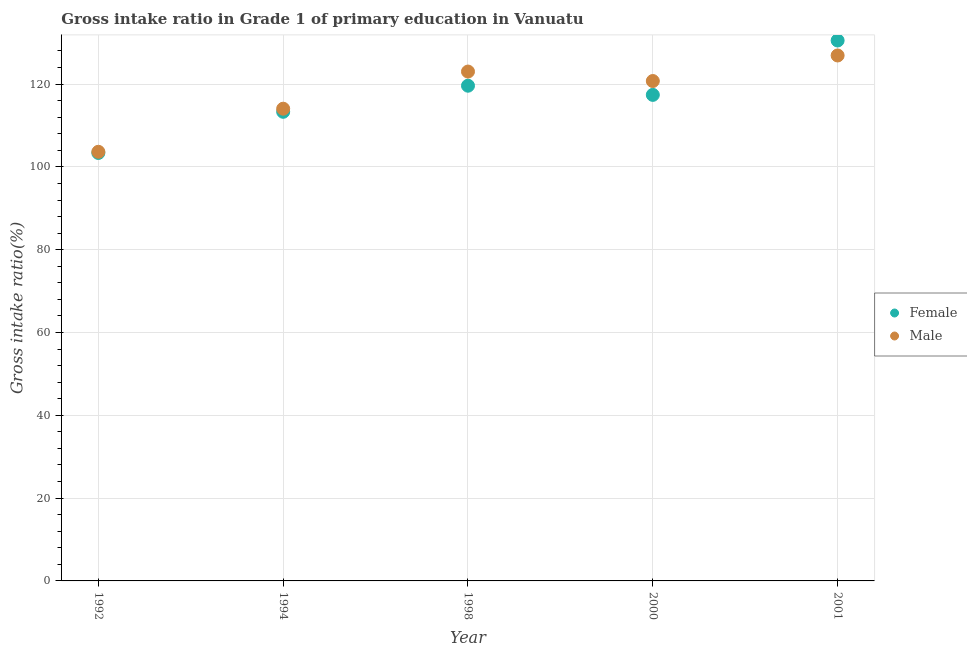How many different coloured dotlines are there?
Keep it short and to the point. 2. Is the number of dotlines equal to the number of legend labels?
Offer a very short reply. Yes. What is the gross intake ratio(male) in 2001?
Provide a succinct answer. 126.9. Across all years, what is the maximum gross intake ratio(female)?
Ensure brevity in your answer.  130.52. Across all years, what is the minimum gross intake ratio(male)?
Your answer should be compact. 103.64. In which year was the gross intake ratio(female) maximum?
Offer a very short reply. 2001. In which year was the gross intake ratio(female) minimum?
Provide a succinct answer. 1992. What is the total gross intake ratio(female) in the graph?
Offer a terse response. 584.18. What is the difference between the gross intake ratio(male) in 1998 and that in 2001?
Provide a succinct answer. -3.88. What is the difference between the gross intake ratio(female) in 1998 and the gross intake ratio(male) in 2000?
Keep it short and to the point. -1.13. What is the average gross intake ratio(male) per year?
Offer a terse response. 117.67. In the year 1992, what is the difference between the gross intake ratio(male) and gross intake ratio(female)?
Provide a succinct answer. 0.28. What is the ratio of the gross intake ratio(female) in 1998 to that in 2000?
Offer a very short reply. 1.02. Is the difference between the gross intake ratio(male) in 1992 and 2000 greater than the difference between the gross intake ratio(female) in 1992 and 2000?
Your answer should be very brief. No. What is the difference between the highest and the second highest gross intake ratio(male)?
Provide a succinct answer. 3.88. What is the difference between the highest and the lowest gross intake ratio(female)?
Your answer should be very brief. 27.16. In how many years, is the gross intake ratio(female) greater than the average gross intake ratio(female) taken over all years?
Ensure brevity in your answer.  3. Is the sum of the gross intake ratio(female) in 1994 and 1998 greater than the maximum gross intake ratio(male) across all years?
Your answer should be very brief. Yes. Does the gross intake ratio(male) monotonically increase over the years?
Give a very brief answer. No. Is the gross intake ratio(female) strictly greater than the gross intake ratio(male) over the years?
Ensure brevity in your answer.  No. Are the values on the major ticks of Y-axis written in scientific E-notation?
Your response must be concise. No. Does the graph contain grids?
Provide a succinct answer. Yes. Where does the legend appear in the graph?
Provide a succinct answer. Center right. What is the title of the graph?
Offer a terse response. Gross intake ratio in Grade 1 of primary education in Vanuatu. Does "Transport services" appear as one of the legend labels in the graph?
Give a very brief answer. No. What is the label or title of the Y-axis?
Make the answer very short. Gross intake ratio(%). What is the Gross intake ratio(%) in Female in 1992?
Ensure brevity in your answer.  103.36. What is the Gross intake ratio(%) in Male in 1992?
Your response must be concise. 103.64. What is the Gross intake ratio(%) of Female in 1994?
Give a very brief answer. 113.3. What is the Gross intake ratio(%) of Male in 1994?
Keep it short and to the point. 114.05. What is the Gross intake ratio(%) of Female in 1998?
Offer a very short reply. 119.6. What is the Gross intake ratio(%) in Male in 1998?
Provide a succinct answer. 123.02. What is the Gross intake ratio(%) of Female in 2000?
Provide a short and direct response. 117.39. What is the Gross intake ratio(%) in Male in 2000?
Give a very brief answer. 120.73. What is the Gross intake ratio(%) of Female in 2001?
Your response must be concise. 130.52. What is the Gross intake ratio(%) of Male in 2001?
Make the answer very short. 126.9. Across all years, what is the maximum Gross intake ratio(%) of Female?
Offer a very short reply. 130.52. Across all years, what is the maximum Gross intake ratio(%) of Male?
Offer a very short reply. 126.9. Across all years, what is the minimum Gross intake ratio(%) of Female?
Offer a terse response. 103.36. Across all years, what is the minimum Gross intake ratio(%) of Male?
Make the answer very short. 103.64. What is the total Gross intake ratio(%) of Female in the graph?
Provide a succinct answer. 584.18. What is the total Gross intake ratio(%) in Male in the graph?
Offer a very short reply. 588.35. What is the difference between the Gross intake ratio(%) of Female in 1992 and that in 1994?
Your response must be concise. -9.94. What is the difference between the Gross intake ratio(%) of Male in 1992 and that in 1994?
Your answer should be compact. -10.41. What is the difference between the Gross intake ratio(%) in Female in 1992 and that in 1998?
Keep it short and to the point. -16.24. What is the difference between the Gross intake ratio(%) in Male in 1992 and that in 1998?
Provide a succinct answer. -19.38. What is the difference between the Gross intake ratio(%) in Female in 1992 and that in 2000?
Your answer should be very brief. -14.03. What is the difference between the Gross intake ratio(%) of Male in 1992 and that in 2000?
Provide a short and direct response. -17.09. What is the difference between the Gross intake ratio(%) of Female in 1992 and that in 2001?
Provide a short and direct response. -27.16. What is the difference between the Gross intake ratio(%) in Male in 1992 and that in 2001?
Give a very brief answer. -23.26. What is the difference between the Gross intake ratio(%) in Female in 1994 and that in 1998?
Your answer should be very brief. -6.3. What is the difference between the Gross intake ratio(%) in Male in 1994 and that in 1998?
Keep it short and to the point. -8.97. What is the difference between the Gross intake ratio(%) of Female in 1994 and that in 2000?
Your answer should be very brief. -4.09. What is the difference between the Gross intake ratio(%) in Male in 1994 and that in 2000?
Offer a terse response. -6.69. What is the difference between the Gross intake ratio(%) in Female in 1994 and that in 2001?
Offer a terse response. -17.22. What is the difference between the Gross intake ratio(%) of Male in 1994 and that in 2001?
Ensure brevity in your answer.  -12.86. What is the difference between the Gross intake ratio(%) of Female in 1998 and that in 2000?
Keep it short and to the point. 2.22. What is the difference between the Gross intake ratio(%) in Male in 1998 and that in 2000?
Offer a very short reply. 2.29. What is the difference between the Gross intake ratio(%) of Female in 1998 and that in 2001?
Offer a terse response. -10.92. What is the difference between the Gross intake ratio(%) in Male in 1998 and that in 2001?
Provide a short and direct response. -3.88. What is the difference between the Gross intake ratio(%) of Female in 2000 and that in 2001?
Make the answer very short. -13.14. What is the difference between the Gross intake ratio(%) in Male in 2000 and that in 2001?
Provide a short and direct response. -6.17. What is the difference between the Gross intake ratio(%) in Female in 1992 and the Gross intake ratio(%) in Male in 1994?
Your answer should be very brief. -10.69. What is the difference between the Gross intake ratio(%) in Female in 1992 and the Gross intake ratio(%) in Male in 1998?
Your answer should be compact. -19.66. What is the difference between the Gross intake ratio(%) in Female in 1992 and the Gross intake ratio(%) in Male in 2000?
Your answer should be compact. -17.37. What is the difference between the Gross intake ratio(%) in Female in 1992 and the Gross intake ratio(%) in Male in 2001?
Offer a very short reply. -23.54. What is the difference between the Gross intake ratio(%) of Female in 1994 and the Gross intake ratio(%) of Male in 1998?
Provide a succinct answer. -9.72. What is the difference between the Gross intake ratio(%) of Female in 1994 and the Gross intake ratio(%) of Male in 2000?
Make the answer very short. -7.43. What is the difference between the Gross intake ratio(%) of Female in 1994 and the Gross intake ratio(%) of Male in 2001?
Give a very brief answer. -13.6. What is the difference between the Gross intake ratio(%) of Female in 1998 and the Gross intake ratio(%) of Male in 2000?
Provide a succinct answer. -1.13. What is the difference between the Gross intake ratio(%) in Female in 1998 and the Gross intake ratio(%) in Male in 2001?
Provide a succinct answer. -7.3. What is the difference between the Gross intake ratio(%) in Female in 2000 and the Gross intake ratio(%) in Male in 2001?
Keep it short and to the point. -9.52. What is the average Gross intake ratio(%) in Female per year?
Provide a succinct answer. 116.84. What is the average Gross intake ratio(%) of Male per year?
Provide a succinct answer. 117.67. In the year 1992, what is the difference between the Gross intake ratio(%) of Female and Gross intake ratio(%) of Male?
Give a very brief answer. -0.28. In the year 1994, what is the difference between the Gross intake ratio(%) in Female and Gross intake ratio(%) in Male?
Offer a very short reply. -0.75. In the year 1998, what is the difference between the Gross intake ratio(%) in Female and Gross intake ratio(%) in Male?
Your response must be concise. -3.42. In the year 2000, what is the difference between the Gross intake ratio(%) of Female and Gross intake ratio(%) of Male?
Ensure brevity in your answer.  -3.35. In the year 2001, what is the difference between the Gross intake ratio(%) of Female and Gross intake ratio(%) of Male?
Provide a succinct answer. 3.62. What is the ratio of the Gross intake ratio(%) of Female in 1992 to that in 1994?
Keep it short and to the point. 0.91. What is the ratio of the Gross intake ratio(%) in Male in 1992 to that in 1994?
Provide a short and direct response. 0.91. What is the ratio of the Gross intake ratio(%) of Female in 1992 to that in 1998?
Your answer should be very brief. 0.86. What is the ratio of the Gross intake ratio(%) of Male in 1992 to that in 1998?
Offer a very short reply. 0.84. What is the ratio of the Gross intake ratio(%) of Female in 1992 to that in 2000?
Give a very brief answer. 0.88. What is the ratio of the Gross intake ratio(%) of Male in 1992 to that in 2000?
Ensure brevity in your answer.  0.86. What is the ratio of the Gross intake ratio(%) in Female in 1992 to that in 2001?
Your answer should be compact. 0.79. What is the ratio of the Gross intake ratio(%) in Male in 1992 to that in 2001?
Offer a terse response. 0.82. What is the ratio of the Gross intake ratio(%) of Female in 1994 to that in 1998?
Make the answer very short. 0.95. What is the ratio of the Gross intake ratio(%) of Male in 1994 to that in 1998?
Provide a short and direct response. 0.93. What is the ratio of the Gross intake ratio(%) in Female in 1994 to that in 2000?
Your answer should be very brief. 0.97. What is the ratio of the Gross intake ratio(%) in Male in 1994 to that in 2000?
Your answer should be very brief. 0.94. What is the ratio of the Gross intake ratio(%) in Female in 1994 to that in 2001?
Make the answer very short. 0.87. What is the ratio of the Gross intake ratio(%) in Male in 1994 to that in 2001?
Offer a very short reply. 0.9. What is the ratio of the Gross intake ratio(%) in Female in 1998 to that in 2000?
Ensure brevity in your answer.  1.02. What is the ratio of the Gross intake ratio(%) in Male in 1998 to that in 2000?
Keep it short and to the point. 1.02. What is the ratio of the Gross intake ratio(%) in Female in 1998 to that in 2001?
Provide a succinct answer. 0.92. What is the ratio of the Gross intake ratio(%) in Male in 1998 to that in 2001?
Offer a very short reply. 0.97. What is the ratio of the Gross intake ratio(%) in Female in 2000 to that in 2001?
Your answer should be compact. 0.9. What is the ratio of the Gross intake ratio(%) in Male in 2000 to that in 2001?
Offer a terse response. 0.95. What is the difference between the highest and the second highest Gross intake ratio(%) of Female?
Keep it short and to the point. 10.92. What is the difference between the highest and the second highest Gross intake ratio(%) of Male?
Your answer should be compact. 3.88. What is the difference between the highest and the lowest Gross intake ratio(%) of Female?
Provide a short and direct response. 27.16. What is the difference between the highest and the lowest Gross intake ratio(%) of Male?
Make the answer very short. 23.26. 